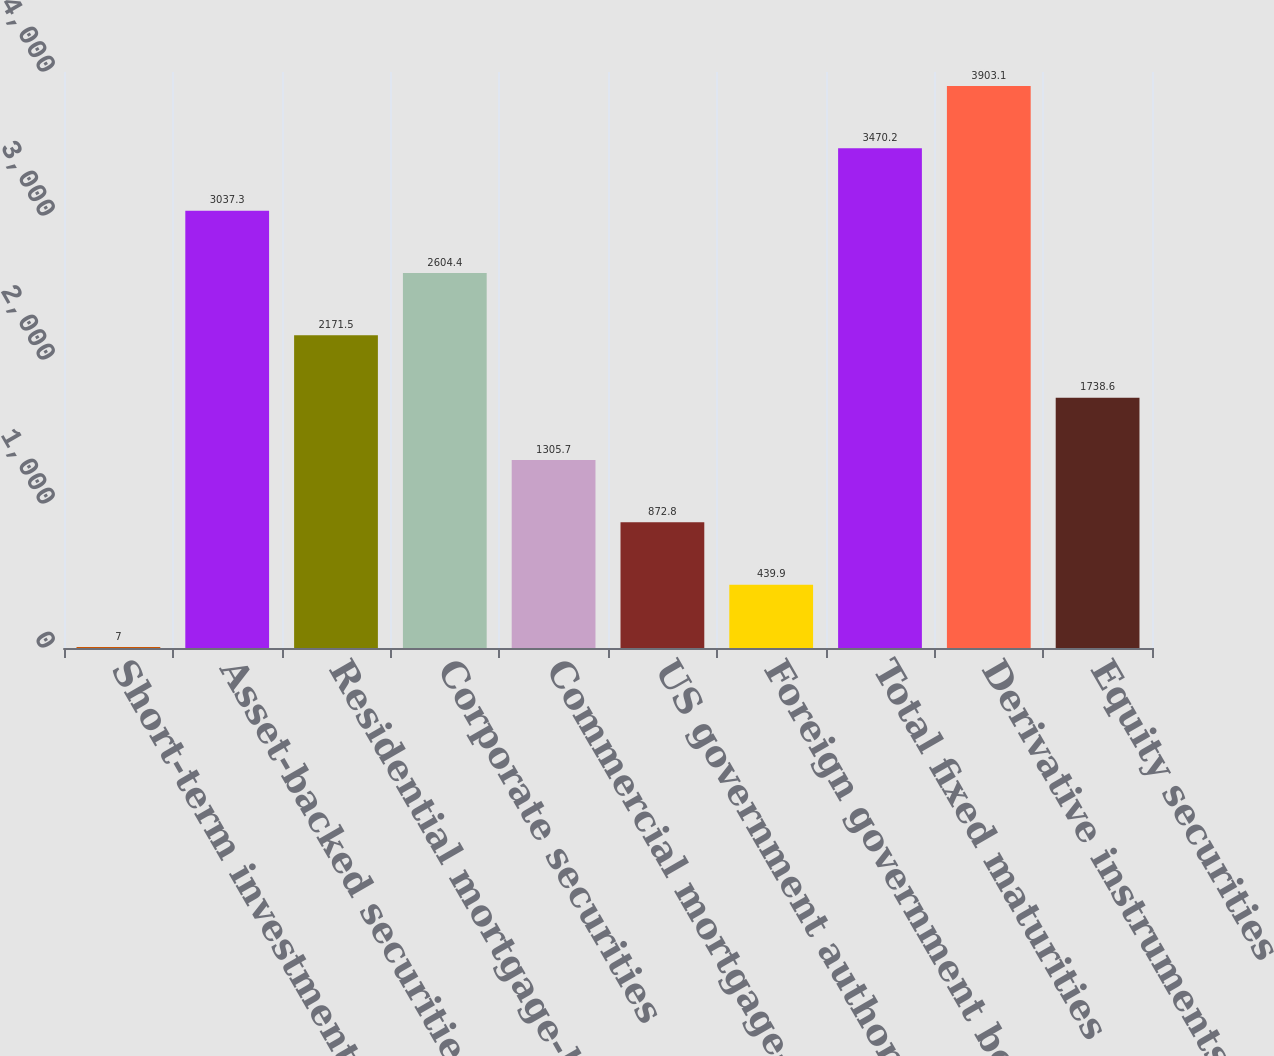Convert chart. <chart><loc_0><loc_0><loc_500><loc_500><bar_chart><fcel>Short-term investments and<fcel>Asset-backed securities<fcel>Residential mortgage-backed<fcel>Corporate securities<fcel>Commercial mortgage-backed<fcel>US government authorities and<fcel>Foreign government bonds<fcel>Total fixed maturities<fcel>Derivative instruments and<fcel>Equity securities<nl><fcel>7<fcel>3037.3<fcel>2171.5<fcel>2604.4<fcel>1305.7<fcel>872.8<fcel>439.9<fcel>3470.2<fcel>3903.1<fcel>1738.6<nl></chart> 